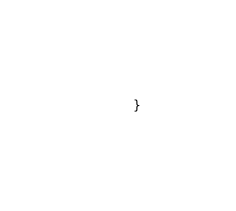<code> <loc_0><loc_0><loc_500><loc_500><_PHP_>}
</code> 